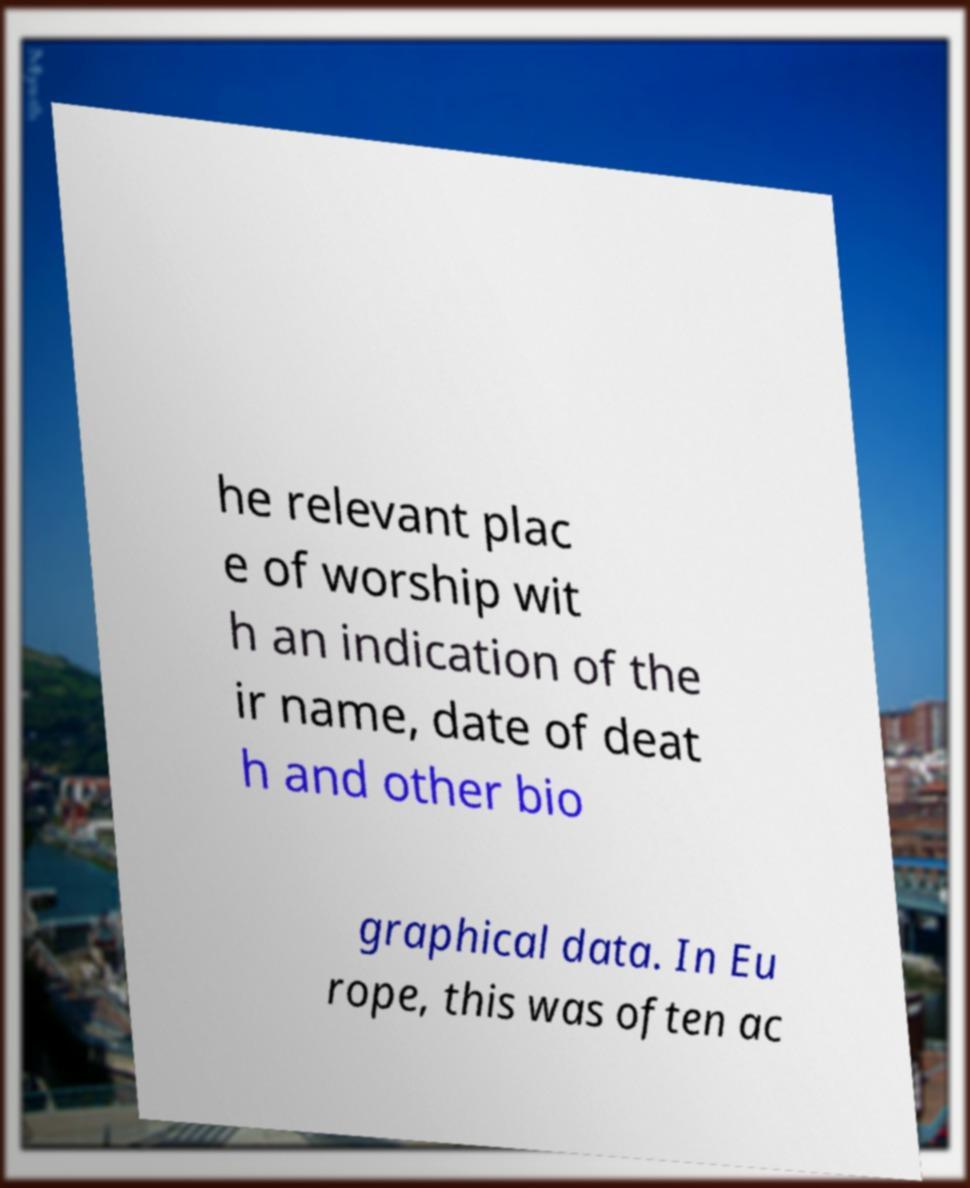Could you assist in decoding the text presented in this image and type it out clearly? he relevant plac e of worship wit h an indication of the ir name, date of deat h and other bio graphical data. In Eu rope, this was often ac 